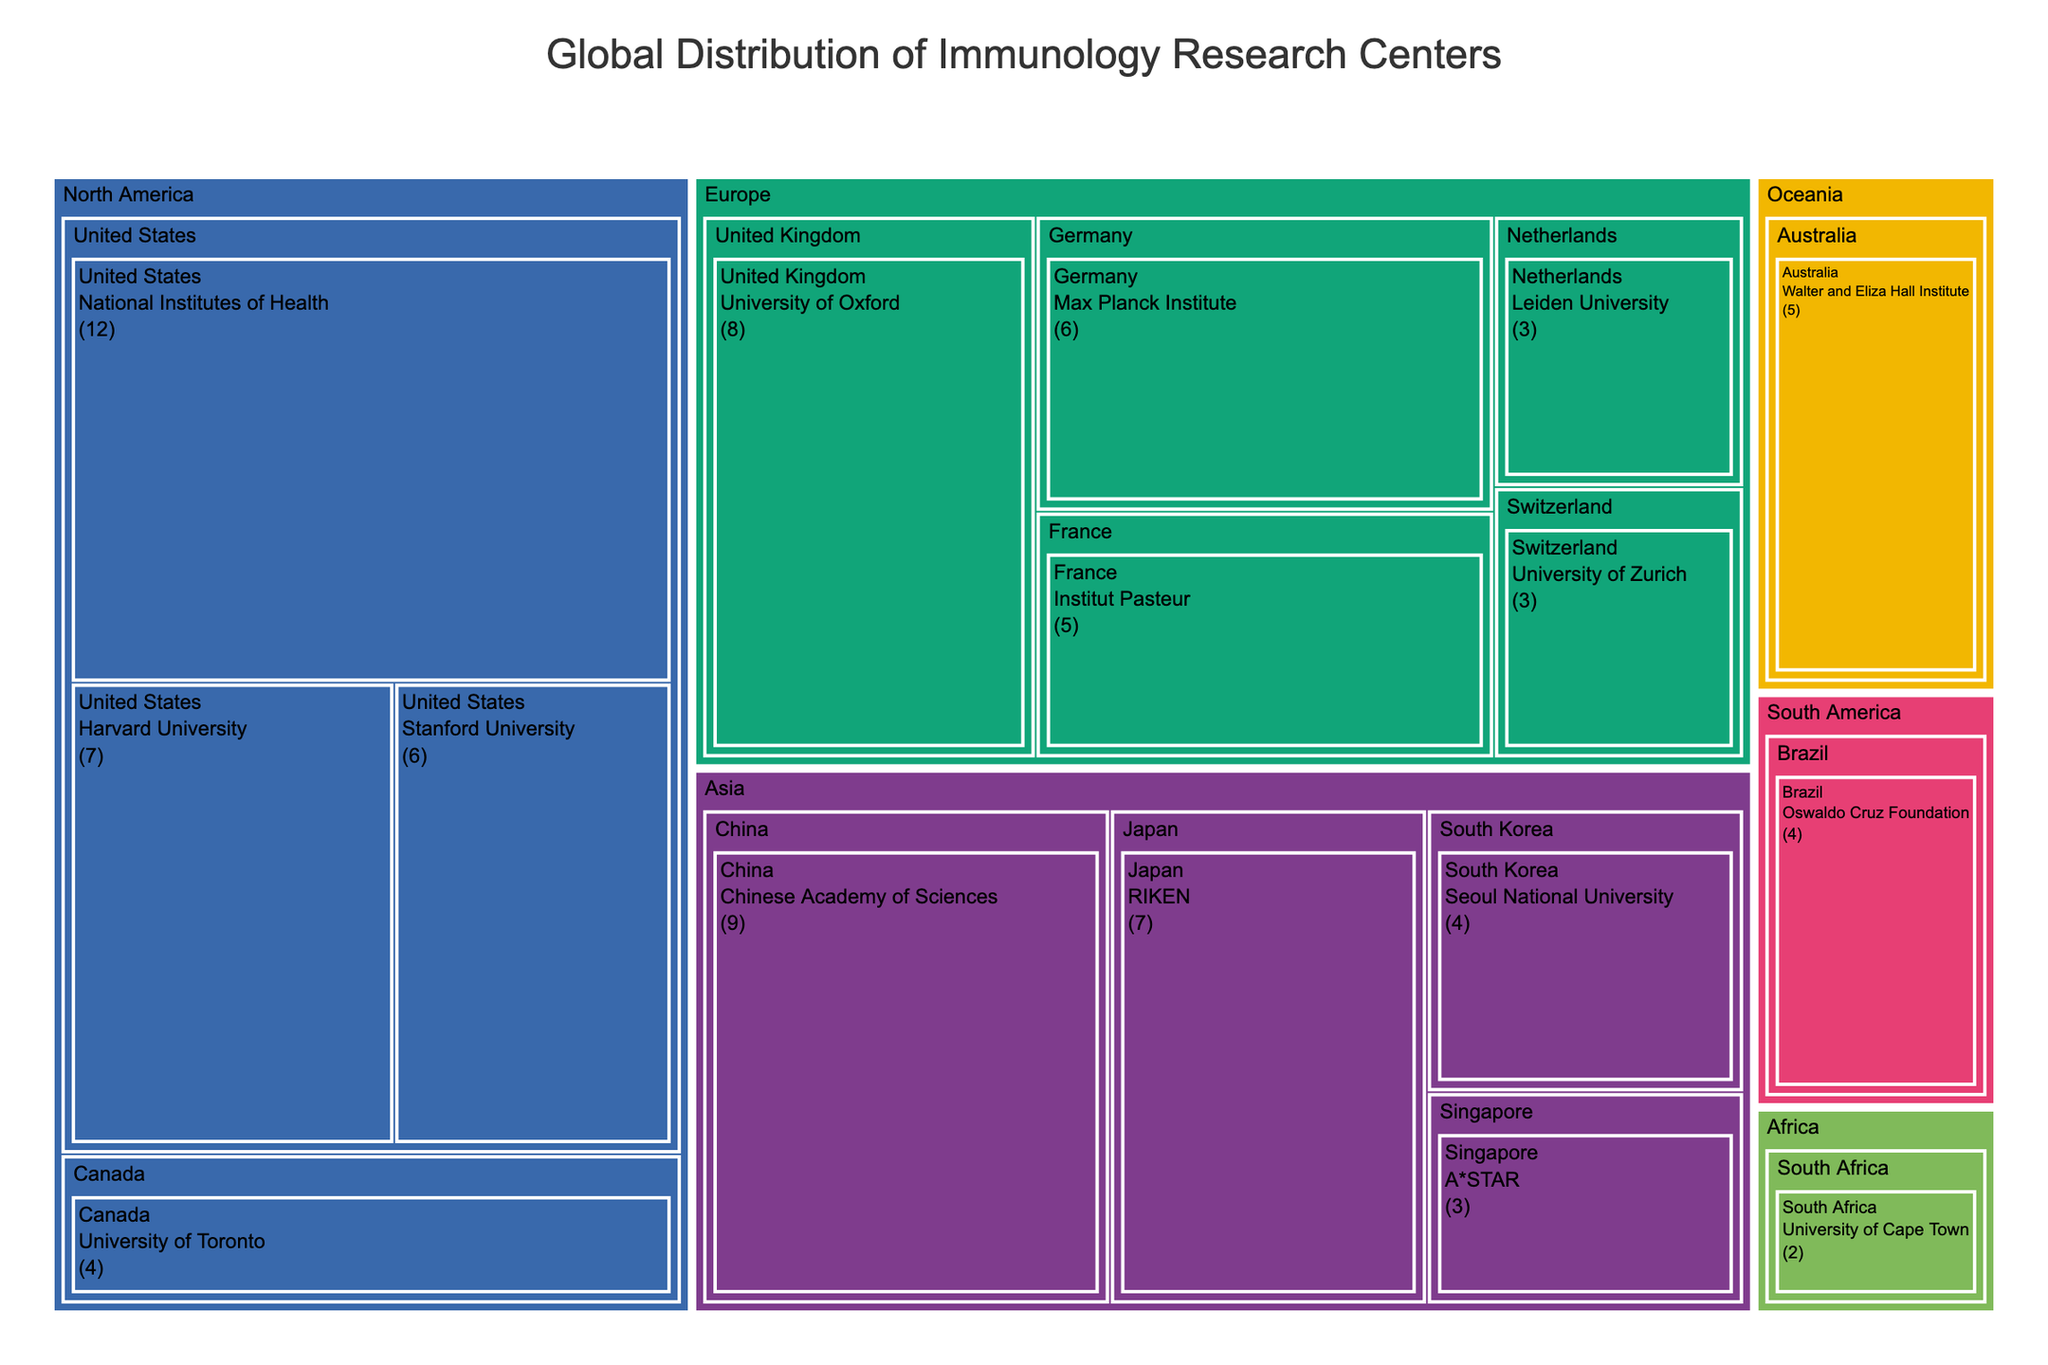Which country in Asia has the most immunology research centers? The treemap shows that China has the highest number of immunology research centers in Asia, with the Chinese Academy of Sciences having 9 centers.
Answer: China How many research centers are there in total in North America? North America has research centers from the United States and Canada. Summing them up: National Institutes of Health (12) + Stanford University (6) + Harvard University (7) + University of Toronto (4) = 29 centers.
Answer: 29 Which continent has the highest number of research centers, and which country within that continent contributes the most? The treemap shows that North America has the highest number of research centers with 29 centers in total. Within North America, the United States contributes the most with 25 centers (National Institutes of Health (12) + Stanford University (6) + Harvard University (7)).
Answer: North America, United States How does the number of research centers in Europe compare to those in Asia? Summing up Europe: University of Oxford (8) + Max Planck Institute (6) + Institut Pasteur (5) + University of Zurich (3) + Leiden University (3) = 25 centers. For Asia: RIKEN (7) + Chinese Academy of Sciences (9) + A*STAR (3) + Seoul National University (4) = 23 centers. So, Europe has 2 more centers than Asia.
Answer: Europe has more centers than Asia by 2 What is the difference in the number of research centers between the country with the most centers and the country with the least centers? The United States (12 + 6 + 7 = 25 centers) has the most research centers. South Africa (2 centers) has the least. The difference is 25 - 2 = 23.
Answer: 23 Which research center in Europe has the highest number of centers? According to the treemap, the University of Oxford in the United Kingdom has the highest number with 8 centers in Europe.
Answer: University of Oxford How many countries in total have immunology research centers? The treemap shows centers in the following countries: United Kingdom, Germany, France, United States, Canada, Japan, China, Singapore, Australia, Brazil, South Africa, Switzerland, South Korea, Netherlands. Counting these, there are 14 countries in total.
Answer: 14 What is the sum of research centers in France and Australia? France has Institut Pasteur with 5 centers. Australia has the Walter and Eliza Hall Institute with 5 centers. Summing them up: 5 + 5 = 10.
Answer: 10 Which countries have only one research center listed? From the data, no country has only one research center; all mentioned countries have more than one research center.
Answer: None 